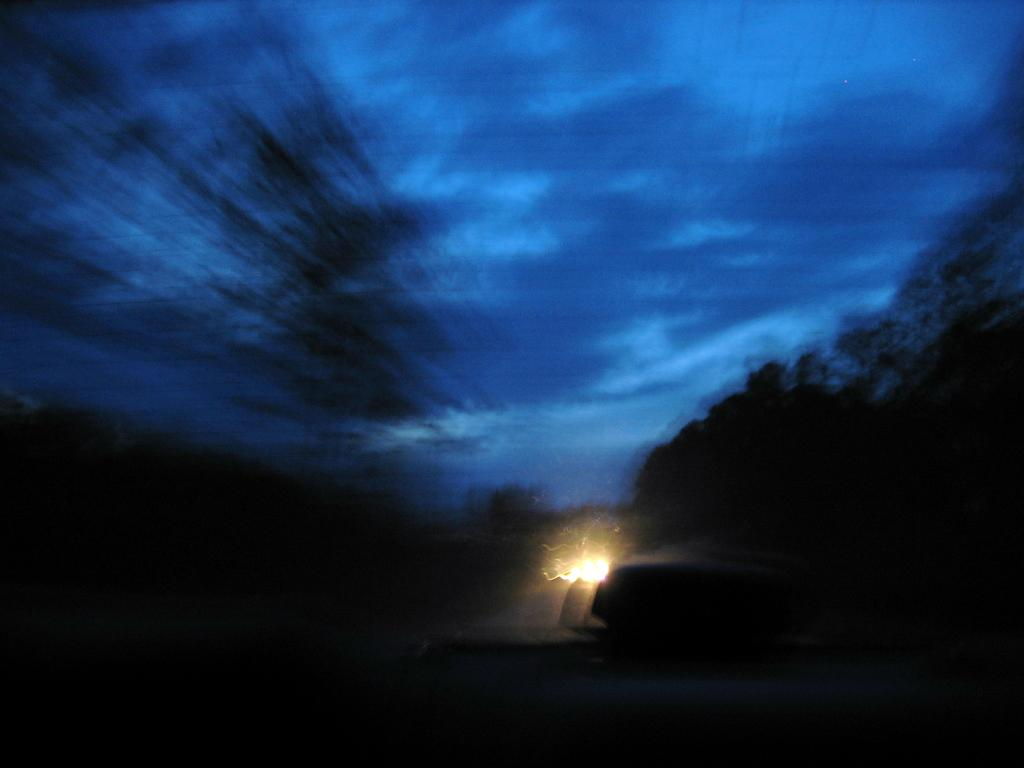What is the source of light in the image? There is a light in the image. What time of day was the image taken? The image was taken during night. What can be seen in the sky at the top of the image? The sky is visible at the top of the image. What type of vegetation is on the right side of the image? There are trees on the right side of the image. What type of thought can be seen in the image? There are no thoughts visible in the image; it is a photograph and does not depict abstract concepts like thoughts. 